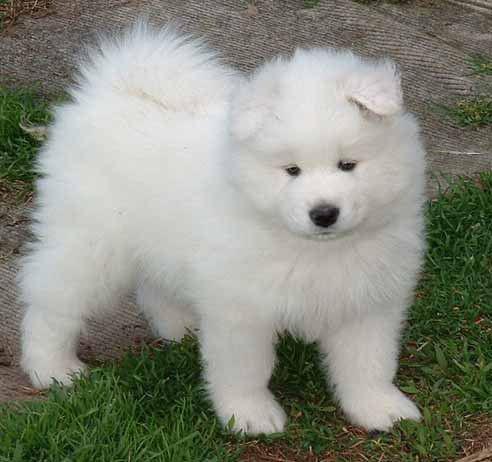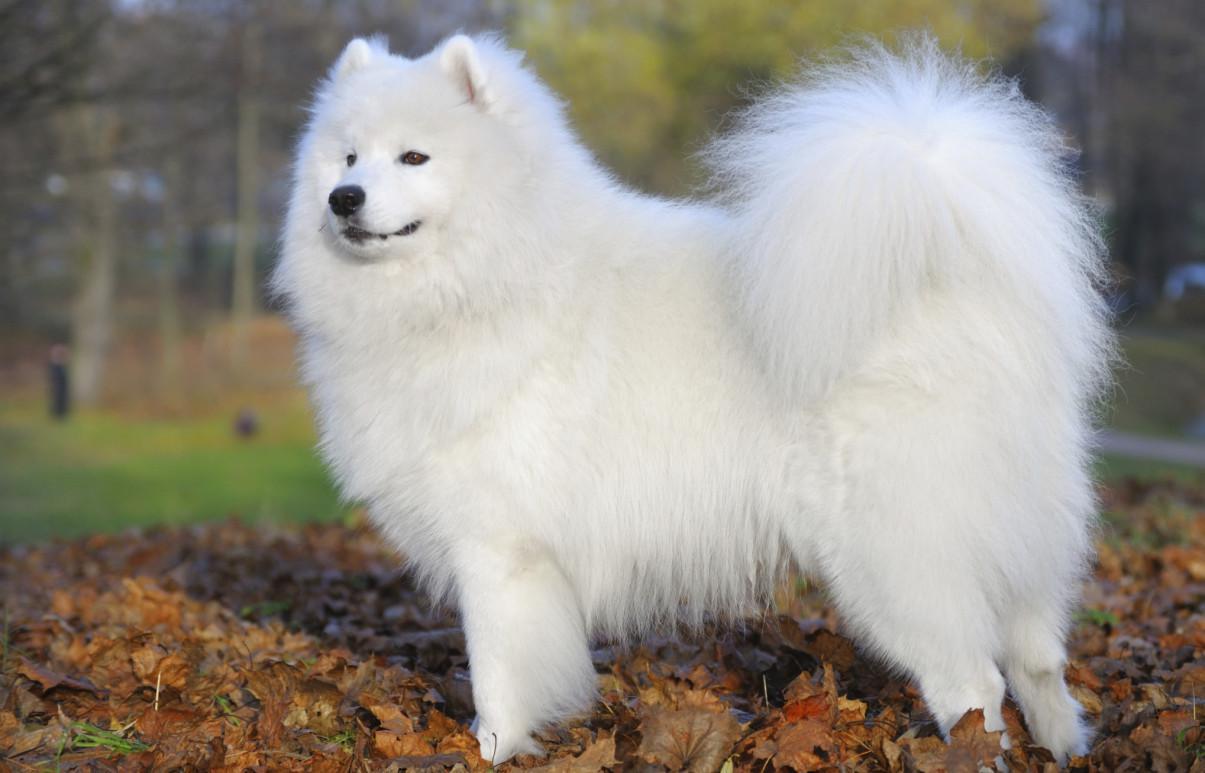The first image is the image on the left, the second image is the image on the right. Evaluate the accuracy of this statement regarding the images: "Each image contains exactly one white dog, and each dog is in the same type of pose.". Is it true? Answer yes or no. Yes. The first image is the image on the left, the second image is the image on the right. Assess this claim about the two images: "Only one dog is contained in each image.". Correct or not? Answer yes or no. Yes. 